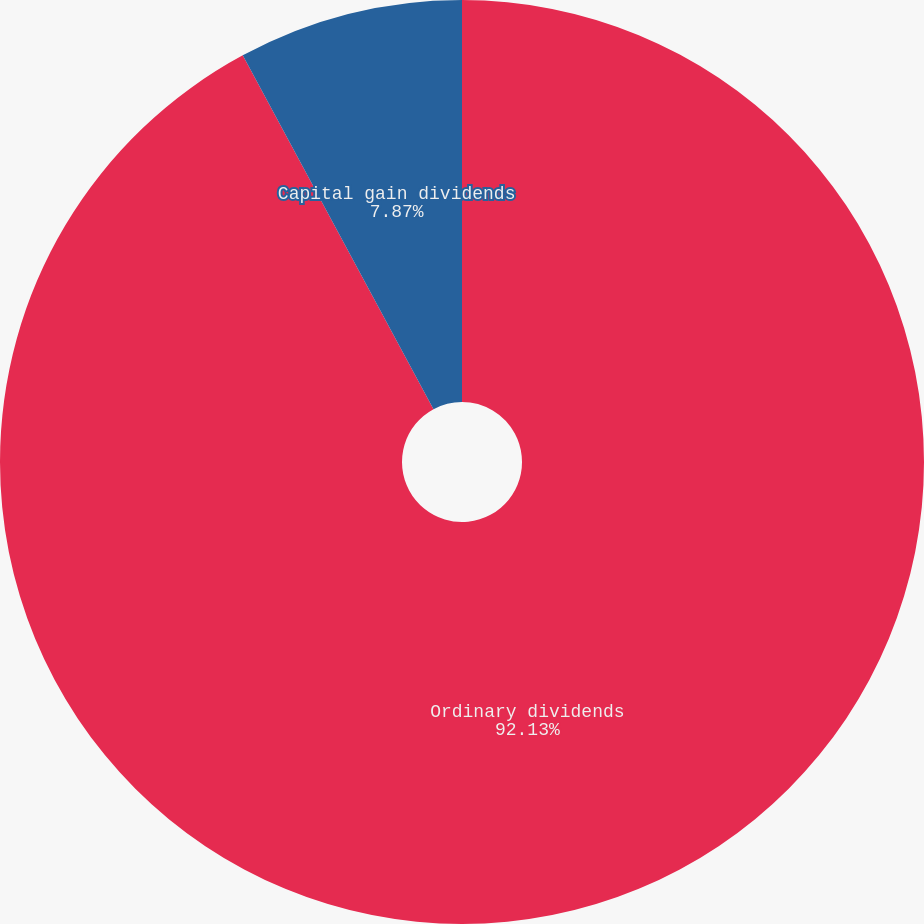Convert chart. <chart><loc_0><loc_0><loc_500><loc_500><pie_chart><fcel>Ordinary dividends<fcel>Capital gain dividends<nl><fcel>92.13%<fcel>7.87%<nl></chart> 